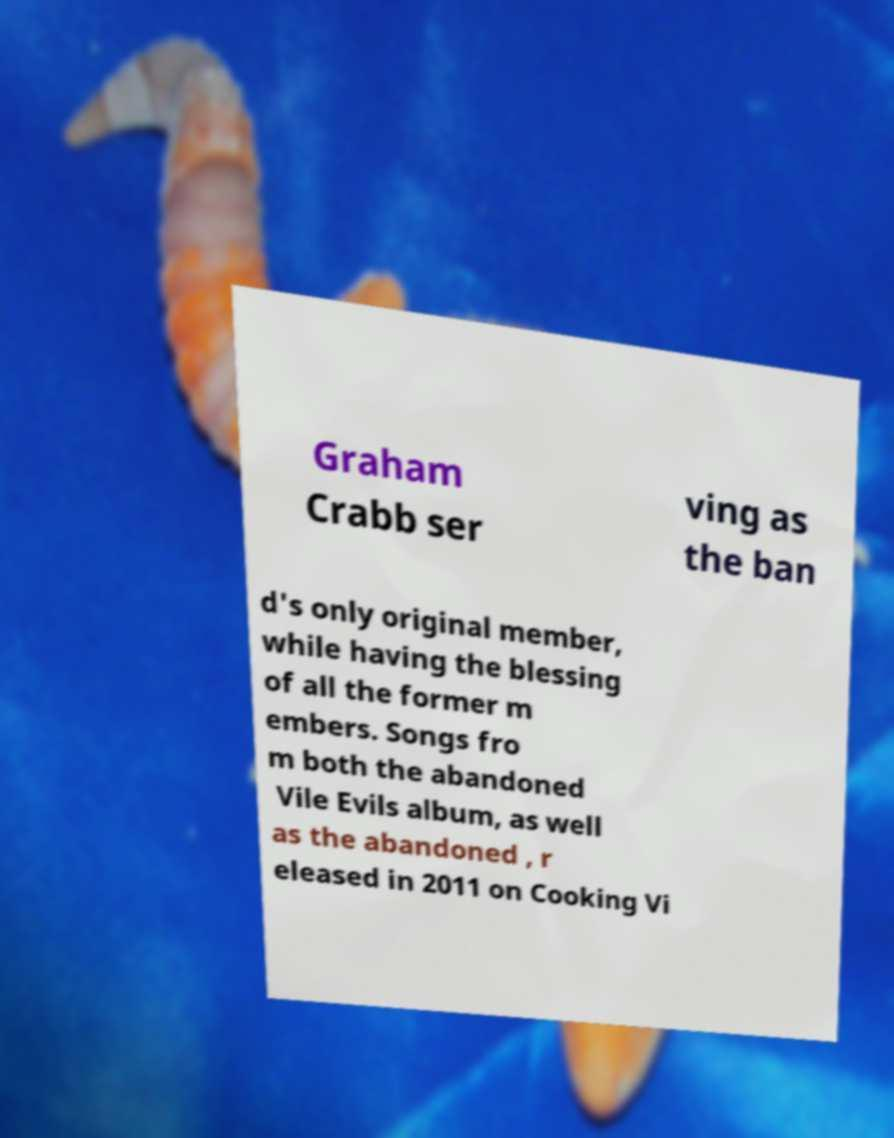Please read and relay the text visible in this image. What does it say? Graham Crabb ser ving as the ban d's only original member, while having the blessing of all the former m embers. Songs fro m both the abandoned Vile Evils album, as well as the abandoned , r eleased in 2011 on Cooking Vi 